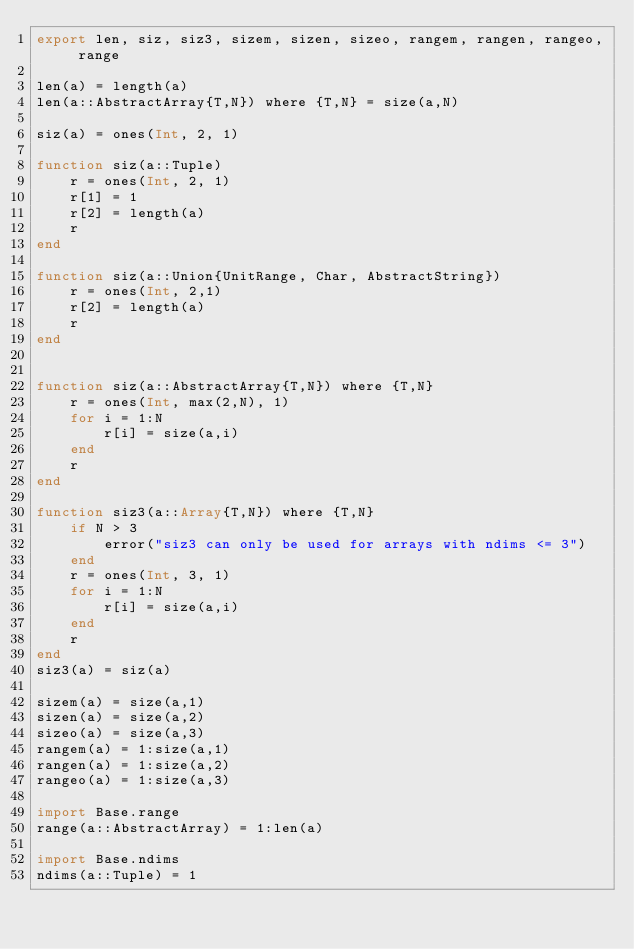Convert code to text. <code><loc_0><loc_0><loc_500><loc_500><_Julia_>export len, siz, siz3, sizem, sizen, sizeo, rangem, rangen, rangeo, range

len(a) = length(a)
len(a::AbstractArray{T,N}) where {T,N} = size(a,N)

siz(a) = ones(Int, 2, 1)

function siz(a::Tuple)
    r = ones(Int, 2, 1)
    r[1] = 1
    r[2] = length(a)
    r
end

function siz(a::Union{UnitRange, Char, AbstractString})
    r = ones(Int, 2,1)
    r[2] = length(a)
    r
end


function siz(a::AbstractArray{T,N}) where {T,N}
    r = ones(Int, max(2,N), 1)
    for i = 1:N
        r[i] = size(a,i)
    end
    r
end

function siz3(a::Array{T,N}) where {T,N}
    if N > 3
        error("siz3 can only be used for arrays with ndims <= 3")
    end
    r = ones(Int, 3, 1)
    for i = 1:N
        r[i] = size(a,i)
    end
    r
end
siz3(a) = siz(a)

sizem(a) = size(a,1)
sizen(a) = size(a,2)
sizeo(a) = size(a,3)
rangem(a) = 1:size(a,1)
rangen(a) = 1:size(a,2)
rangeo(a) = 1:size(a,3)

import Base.range
range(a::AbstractArray) = 1:len(a)

import Base.ndims
ndims(a::Tuple) = 1
</code> 